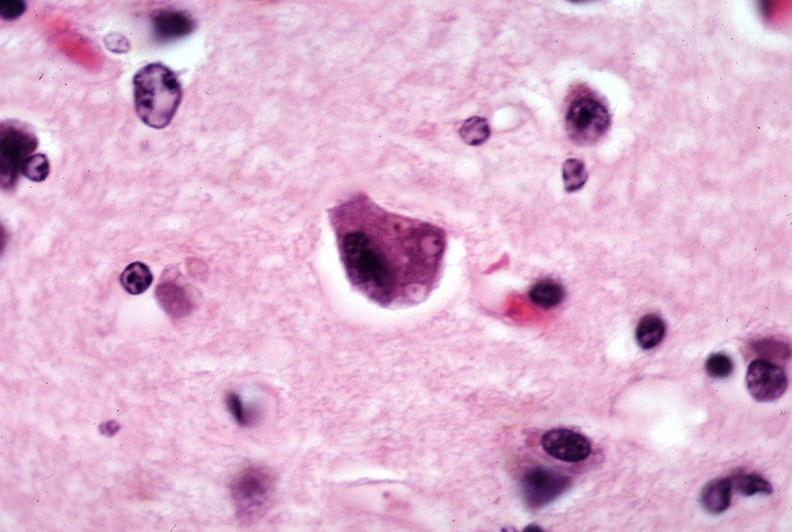what is present?
Answer the question using a single word or phrase. Nervous 